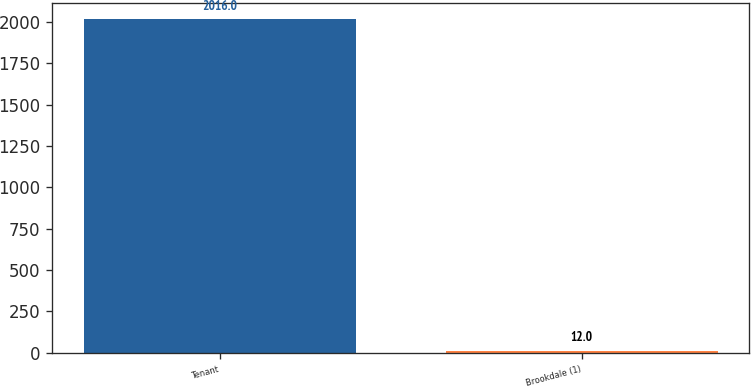Convert chart. <chart><loc_0><loc_0><loc_500><loc_500><bar_chart><fcel>Tenant<fcel>Brookdale (1)<nl><fcel>2016<fcel>12<nl></chart> 